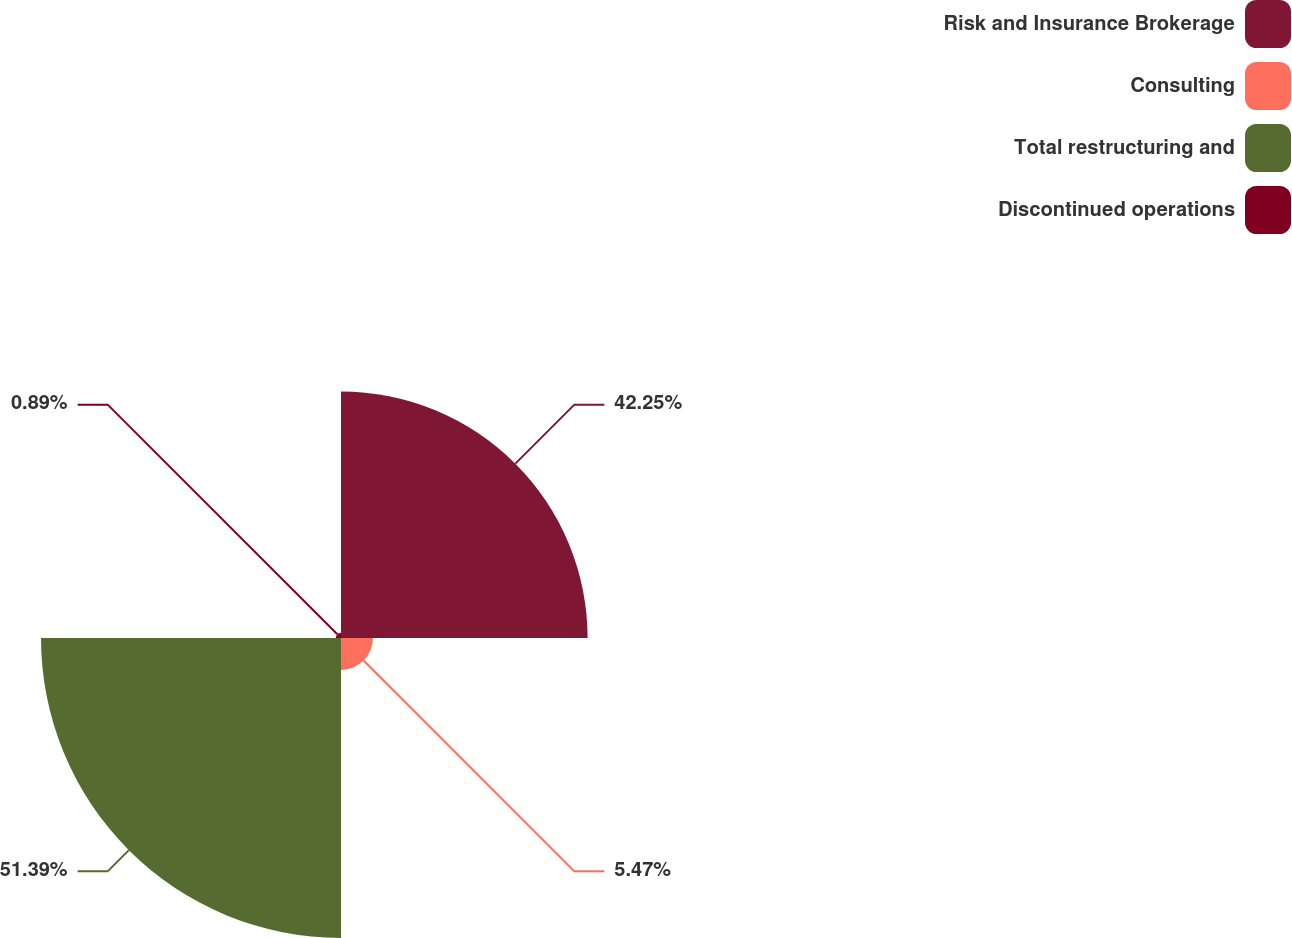<chart> <loc_0><loc_0><loc_500><loc_500><pie_chart><fcel>Risk and Insurance Brokerage<fcel>Consulting<fcel>Total restructuring and<fcel>Discontinued operations<nl><fcel>42.25%<fcel>5.47%<fcel>51.4%<fcel>0.89%<nl></chart> 